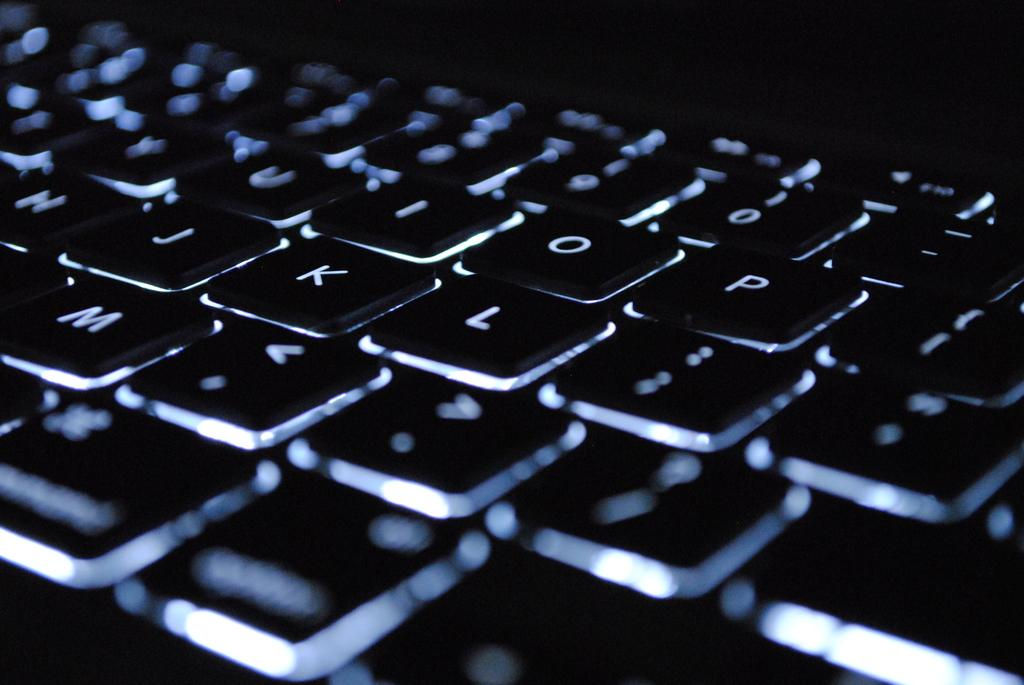<image>
Share a concise interpretation of the image provided. A keyboard showing the letters Y, U, I, O, P, H, J, K, L, and M. 